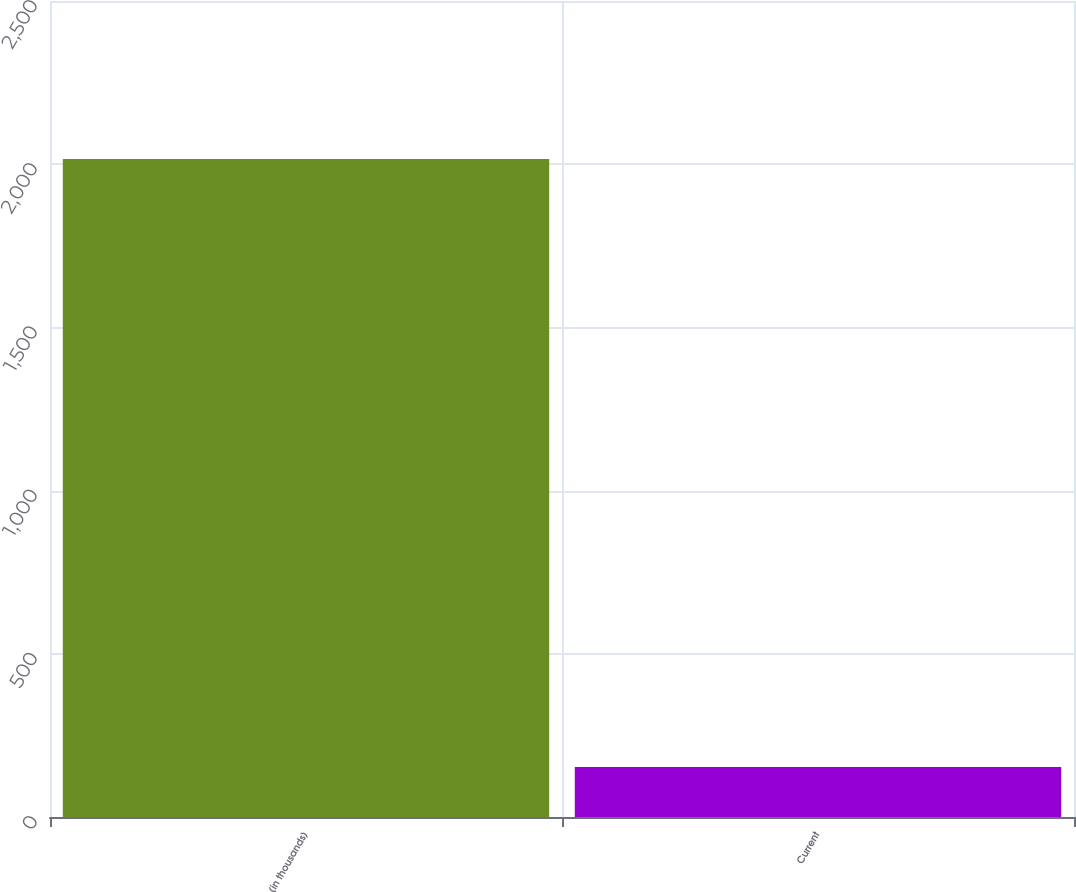Convert chart. <chart><loc_0><loc_0><loc_500><loc_500><bar_chart><fcel>(in thousands)<fcel>Current<nl><fcel>2016<fcel>153<nl></chart> 